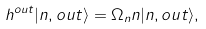<formula> <loc_0><loc_0><loc_500><loc_500>h ^ { o u t } | n , o u t \rangle = \Omega _ { n } n | n , o u t \rangle ,</formula> 